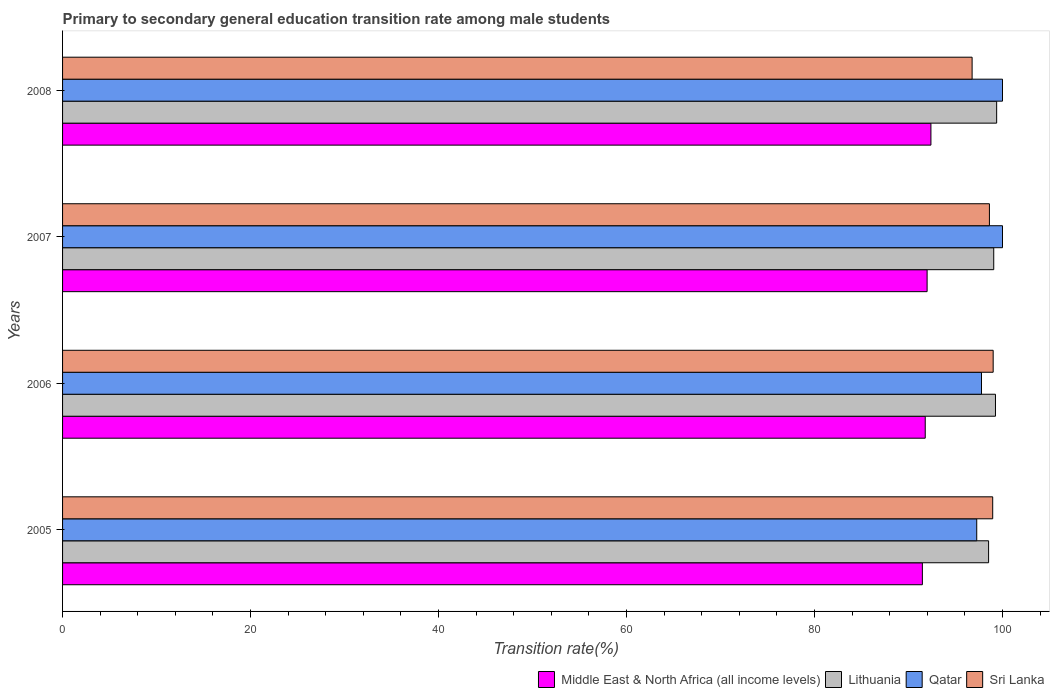How many different coloured bars are there?
Provide a short and direct response. 4. How many groups of bars are there?
Give a very brief answer. 4. Are the number of bars on each tick of the Y-axis equal?
Give a very brief answer. Yes. How many bars are there on the 2nd tick from the top?
Keep it short and to the point. 4. How many bars are there on the 2nd tick from the bottom?
Your answer should be compact. 4. In how many cases, is the number of bars for a given year not equal to the number of legend labels?
Keep it short and to the point. 0. What is the transition rate in Lithuania in 2006?
Your response must be concise. 99.25. Across all years, what is the minimum transition rate in Qatar?
Provide a succinct answer. 97.26. In which year was the transition rate in Middle East & North Africa (all income levels) maximum?
Make the answer very short. 2008. What is the total transition rate in Qatar in the graph?
Ensure brevity in your answer.  395.03. What is the difference between the transition rate in Lithuania in 2005 and that in 2008?
Make the answer very short. -0.86. What is the difference between the transition rate in Middle East & North Africa (all income levels) in 2006 and the transition rate in Qatar in 2008?
Your response must be concise. -8.22. What is the average transition rate in Qatar per year?
Provide a succinct answer. 98.76. In the year 2005, what is the difference between the transition rate in Lithuania and transition rate in Middle East & North Africa (all income levels)?
Make the answer very short. 7.04. What is the ratio of the transition rate in Middle East & North Africa (all income levels) in 2007 to that in 2008?
Keep it short and to the point. 1. What is the difference between the highest and the second highest transition rate in Lithuania?
Offer a terse response. 0.13. What is the difference between the highest and the lowest transition rate in Middle East & North Africa (all income levels)?
Your answer should be very brief. 0.91. Is it the case that in every year, the sum of the transition rate in Sri Lanka and transition rate in Qatar is greater than the sum of transition rate in Middle East & North Africa (all income levels) and transition rate in Lithuania?
Keep it short and to the point. Yes. What does the 1st bar from the top in 2006 represents?
Your response must be concise. Sri Lanka. What does the 4th bar from the bottom in 2007 represents?
Provide a succinct answer. Sri Lanka. Is it the case that in every year, the sum of the transition rate in Sri Lanka and transition rate in Middle East & North Africa (all income levels) is greater than the transition rate in Qatar?
Offer a terse response. Yes. How many bars are there?
Provide a short and direct response. 16. Are the values on the major ticks of X-axis written in scientific E-notation?
Keep it short and to the point. No. Does the graph contain grids?
Provide a succinct answer. No. How many legend labels are there?
Offer a very short reply. 4. What is the title of the graph?
Make the answer very short. Primary to secondary general education transition rate among male students. Does "Uruguay" appear as one of the legend labels in the graph?
Provide a short and direct response. No. What is the label or title of the X-axis?
Give a very brief answer. Transition rate(%). What is the label or title of the Y-axis?
Offer a terse response. Years. What is the Transition rate(%) in Middle East & North Africa (all income levels) in 2005?
Provide a succinct answer. 91.48. What is the Transition rate(%) in Lithuania in 2005?
Offer a terse response. 98.52. What is the Transition rate(%) in Qatar in 2005?
Offer a terse response. 97.26. What is the Transition rate(%) of Sri Lanka in 2005?
Your answer should be compact. 98.96. What is the Transition rate(%) in Middle East & North Africa (all income levels) in 2006?
Keep it short and to the point. 91.78. What is the Transition rate(%) in Lithuania in 2006?
Ensure brevity in your answer.  99.25. What is the Transition rate(%) in Qatar in 2006?
Your answer should be compact. 97.77. What is the Transition rate(%) of Sri Lanka in 2006?
Your answer should be compact. 99.01. What is the Transition rate(%) in Middle East & North Africa (all income levels) in 2007?
Your response must be concise. 91.98. What is the Transition rate(%) in Lithuania in 2007?
Make the answer very short. 99.07. What is the Transition rate(%) of Sri Lanka in 2007?
Make the answer very short. 98.61. What is the Transition rate(%) in Middle East & North Africa (all income levels) in 2008?
Keep it short and to the point. 92.38. What is the Transition rate(%) in Lithuania in 2008?
Keep it short and to the point. 99.38. What is the Transition rate(%) in Sri Lanka in 2008?
Your response must be concise. 96.77. Across all years, what is the maximum Transition rate(%) in Middle East & North Africa (all income levels)?
Your answer should be compact. 92.38. Across all years, what is the maximum Transition rate(%) of Lithuania?
Offer a terse response. 99.38. Across all years, what is the maximum Transition rate(%) of Sri Lanka?
Offer a terse response. 99.01. Across all years, what is the minimum Transition rate(%) in Middle East & North Africa (all income levels)?
Offer a terse response. 91.48. Across all years, what is the minimum Transition rate(%) in Lithuania?
Your response must be concise. 98.52. Across all years, what is the minimum Transition rate(%) in Qatar?
Keep it short and to the point. 97.26. Across all years, what is the minimum Transition rate(%) of Sri Lanka?
Keep it short and to the point. 96.77. What is the total Transition rate(%) of Middle East & North Africa (all income levels) in the graph?
Your response must be concise. 367.62. What is the total Transition rate(%) of Lithuania in the graph?
Your answer should be compact. 396.22. What is the total Transition rate(%) of Qatar in the graph?
Ensure brevity in your answer.  395.02. What is the total Transition rate(%) of Sri Lanka in the graph?
Provide a short and direct response. 393.34. What is the difference between the Transition rate(%) in Middle East & North Africa (all income levels) in 2005 and that in 2006?
Provide a succinct answer. -0.3. What is the difference between the Transition rate(%) of Lithuania in 2005 and that in 2006?
Your answer should be compact. -0.73. What is the difference between the Transition rate(%) in Qatar in 2005 and that in 2006?
Give a very brief answer. -0.51. What is the difference between the Transition rate(%) in Sri Lanka in 2005 and that in 2006?
Keep it short and to the point. -0.05. What is the difference between the Transition rate(%) of Middle East & North Africa (all income levels) in 2005 and that in 2007?
Ensure brevity in your answer.  -0.5. What is the difference between the Transition rate(%) in Lithuania in 2005 and that in 2007?
Ensure brevity in your answer.  -0.55. What is the difference between the Transition rate(%) of Qatar in 2005 and that in 2007?
Provide a succinct answer. -2.74. What is the difference between the Transition rate(%) of Sri Lanka in 2005 and that in 2007?
Provide a short and direct response. 0.35. What is the difference between the Transition rate(%) in Middle East & North Africa (all income levels) in 2005 and that in 2008?
Provide a succinct answer. -0.91. What is the difference between the Transition rate(%) of Lithuania in 2005 and that in 2008?
Offer a very short reply. -0.86. What is the difference between the Transition rate(%) of Qatar in 2005 and that in 2008?
Your answer should be very brief. -2.74. What is the difference between the Transition rate(%) in Sri Lanka in 2005 and that in 2008?
Provide a succinct answer. 2.19. What is the difference between the Transition rate(%) of Middle East & North Africa (all income levels) in 2006 and that in 2007?
Your answer should be compact. -0.2. What is the difference between the Transition rate(%) of Lithuania in 2006 and that in 2007?
Provide a succinct answer. 0.18. What is the difference between the Transition rate(%) in Qatar in 2006 and that in 2007?
Offer a terse response. -2.23. What is the difference between the Transition rate(%) of Sri Lanka in 2006 and that in 2007?
Keep it short and to the point. 0.4. What is the difference between the Transition rate(%) in Middle East & North Africa (all income levels) in 2006 and that in 2008?
Your answer should be compact. -0.6. What is the difference between the Transition rate(%) of Lithuania in 2006 and that in 2008?
Offer a terse response. -0.13. What is the difference between the Transition rate(%) in Qatar in 2006 and that in 2008?
Keep it short and to the point. -2.23. What is the difference between the Transition rate(%) in Sri Lanka in 2006 and that in 2008?
Provide a short and direct response. 2.24. What is the difference between the Transition rate(%) in Middle East & North Africa (all income levels) in 2007 and that in 2008?
Your answer should be very brief. -0.4. What is the difference between the Transition rate(%) in Lithuania in 2007 and that in 2008?
Provide a short and direct response. -0.31. What is the difference between the Transition rate(%) of Qatar in 2007 and that in 2008?
Provide a short and direct response. 0. What is the difference between the Transition rate(%) of Sri Lanka in 2007 and that in 2008?
Make the answer very short. 1.84. What is the difference between the Transition rate(%) in Middle East & North Africa (all income levels) in 2005 and the Transition rate(%) in Lithuania in 2006?
Your answer should be very brief. -7.78. What is the difference between the Transition rate(%) in Middle East & North Africa (all income levels) in 2005 and the Transition rate(%) in Qatar in 2006?
Your response must be concise. -6.29. What is the difference between the Transition rate(%) of Middle East & North Africa (all income levels) in 2005 and the Transition rate(%) of Sri Lanka in 2006?
Your answer should be compact. -7.53. What is the difference between the Transition rate(%) in Lithuania in 2005 and the Transition rate(%) in Qatar in 2006?
Make the answer very short. 0.75. What is the difference between the Transition rate(%) in Lithuania in 2005 and the Transition rate(%) in Sri Lanka in 2006?
Provide a short and direct response. -0.49. What is the difference between the Transition rate(%) in Qatar in 2005 and the Transition rate(%) in Sri Lanka in 2006?
Offer a terse response. -1.75. What is the difference between the Transition rate(%) in Middle East & North Africa (all income levels) in 2005 and the Transition rate(%) in Lithuania in 2007?
Keep it short and to the point. -7.59. What is the difference between the Transition rate(%) in Middle East & North Africa (all income levels) in 2005 and the Transition rate(%) in Qatar in 2007?
Give a very brief answer. -8.52. What is the difference between the Transition rate(%) in Middle East & North Africa (all income levels) in 2005 and the Transition rate(%) in Sri Lanka in 2007?
Make the answer very short. -7.13. What is the difference between the Transition rate(%) in Lithuania in 2005 and the Transition rate(%) in Qatar in 2007?
Provide a short and direct response. -1.48. What is the difference between the Transition rate(%) in Lithuania in 2005 and the Transition rate(%) in Sri Lanka in 2007?
Provide a short and direct response. -0.09. What is the difference between the Transition rate(%) of Qatar in 2005 and the Transition rate(%) of Sri Lanka in 2007?
Keep it short and to the point. -1.35. What is the difference between the Transition rate(%) in Middle East & North Africa (all income levels) in 2005 and the Transition rate(%) in Lithuania in 2008?
Provide a short and direct response. -7.9. What is the difference between the Transition rate(%) of Middle East & North Africa (all income levels) in 2005 and the Transition rate(%) of Qatar in 2008?
Your response must be concise. -8.52. What is the difference between the Transition rate(%) in Middle East & North Africa (all income levels) in 2005 and the Transition rate(%) in Sri Lanka in 2008?
Offer a very short reply. -5.29. What is the difference between the Transition rate(%) of Lithuania in 2005 and the Transition rate(%) of Qatar in 2008?
Ensure brevity in your answer.  -1.48. What is the difference between the Transition rate(%) of Lithuania in 2005 and the Transition rate(%) of Sri Lanka in 2008?
Provide a succinct answer. 1.75. What is the difference between the Transition rate(%) in Qatar in 2005 and the Transition rate(%) in Sri Lanka in 2008?
Your answer should be compact. 0.49. What is the difference between the Transition rate(%) in Middle East & North Africa (all income levels) in 2006 and the Transition rate(%) in Lithuania in 2007?
Provide a short and direct response. -7.29. What is the difference between the Transition rate(%) in Middle East & North Africa (all income levels) in 2006 and the Transition rate(%) in Qatar in 2007?
Give a very brief answer. -8.22. What is the difference between the Transition rate(%) in Middle East & North Africa (all income levels) in 2006 and the Transition rate(%) in Sri Lanka in 2007?
Keep it short and to the point. -6.83. What is the difference between the Transition rate(%) in Lithuania in 2006 and the Transition rate(%) in Qatar in 2007?
Ensure brevity in your answer.  -0.75. What is the difference between the Transition rate(%) in Lithuania in 2006 and the Transition rate(%) in Sri Lanka in 2007?
Ensure brevity in your answer.  0.64. What is the difference between the Transition rate(%) of Qatar in 2006 and the Transition rate(%) of Sri Lanka in 2007?
Your response must be concise. -0.84. What is the difference between the Transition rate(%) of Middle East & North Africa (all income levels) in 2006 and the Transition rate(%) of Lithuania in 2008?
Make the answer very short. -7.6. What is the difference between the Transition rate(%) in Middle East & North Africa (all income levels) in 2006 and the Transition rate(%) in Qatar in 2008?
Offer a terse response. -8.22. What is the difference between the Transition rate(%) in Middle East & North Africa (all income levels) in 2006 and the Transition rate(%) in Sri Lanka in 2008?
Provide a succinct answer. -4.99. What is the difference between the Transition rate(%) in Lithuania in 2006 and the Transition rate(%) in Qatar in 2008?
Provide a succinct answer. -0.75. What is the difference between the Transition rate(%) of Lithuania in 2006 and the Transition rate(%) of Sri Lanka in 2008?
Your answer should be compact. 2.48. What is the difference between the Transition rate(%) of Middle East & North Africa (all income levels) in 2007 and the Transition rate(%) of Lithuania in 2008?
Ensure brevity in your answer.  -7.4. What is the difference between the Transition rate(%) of Middle East & North Africa (all income levels) in 2007 and the Transition rate(%) of Qatar in 2008?
Your answer should be compact. -8.02. What is the difference between the Transition rate(%) of Middle East & North Africa (all income levels) in 2007 and the Transition rate(%) of Sri Lanka in 2008?
Keep it short and to the point. -4.79. What is the difference between the Transition rate(%) in Lithuania in 2007 and the Transition rate(%) in Qatar in 2008?
Your answer should be very brief. -0.93. What is the difference between the Transition rate(%) of Lithuania in 2007 and the Transition rate(%) of Sri Lanka in 2008?
Offer a very short reply. 2.3. What is the difference between the Transition rate(%) in Qatar in 2007 and the Transition rate(%) in Sri Lanka in 2008?
Ensure brevity in your answer.  3.23. What is the average Transition rate(%) of Middle East & North Africa (all income levels) per year?
Keep it short and to the point. 91.9. What is the average Transition rate(%) of Lithuania per year?
Your answer should be very brief. 99.05. What is the average Transition rate(%) of Qatar per year?
Provide a short and direct response. 98.76. What is the average Transition rate(%) of Sri Lanka per year?
Offer a terse response. 98.34. In the year 2005, what is the difference between the Transition rate(%) in Middle East & North Africa (all income levels) and Transition rate(%) in Lithuania?
Offer a terse response. -7.04. In the year 2005, what is the difference between the Transition rate(%) of Middle East & North Africa (all income levels) and Transition rate(%) of Qatar?
Provide a succinct answer. -5.78. In the year 2005, what is the difference between the Transition rate(%) in Middle East & North Africa (all income levels) and Transition rate(%) in Sri Lanka?
Provide a short and direct response. -7.48. In the year 2005, what is the difference between the Transition rate(%) in Lithuania and Transition rate(%) in Qatar?
Provide a succinct answer. 1.26. In the year 2005, what is the difference between the Transition rate(%) of Lithuania and Transition rate(%) of Sri Lanka?
Your response must be concise. -0.44. In the year 2005, what is the difference between the Transition rate(%) in Qatar and Transition rate(%) in Sri Lanka?
Make the answer very short. -1.7. In the year 2006, what is the difference between the Transition rate(%) in Middle East & North Africa (all income levels) and Transition rate(%) in Lithuania?
Give a very brief answer. -7.47. In the year 2006, what is the difference between the Transition rate(%) of Middle East & North Africa (all income levels) and Transition rate(%) of Qatar?
Keep it short and to the point. -5.99. In the year 2006, what is the difference between the Transition rate(%) of Middle East & North Africa (all income levels) and Transition rate(%) of Sri Lanka?
Give a very brief answer. -7.23. In the year 2006, what is the difference between the Transition rate(%) in Lithuania and Transition rate(%) in Qatar?
Provide a short and direct response. 1.49. In the year 2006, what is the difference between the Transition rate(%) of Lithuania and Transition rate(%) of Sri Lanka?
Your response must be concise. 0.24. In the year 2006, what is the difference between the Transition rate(%) of Qatar and Transition rate(%) of Sri Lanka?
Offer a terse response. -1.24. In the year 2007, what is the difference between the Transition rate(%) of Middle East & North Africa (all income levels) and Transition rate(%) of Lithuania?
Make the answer very short. -7.09. In the year 2007, what is the difference between the Transition rate(%) in Middle East & North Africa (all income levels) and Transition rate(%) in Qatar?
Make the answer very short. -8.02. In the year 2007, what is the difference between the Transition rate(%) in Middle East & North Africa (all income levels) and Transition rate(%) in Sri Lanka?
Offer a terse response. -6.63. In the year 2007, what is the difference between the Transition rate(%) in Lithuania and Transition rate(%) in Qatar?
Ensure brevity in your answer.  -0.93. In the year 2007, what is the difference between the Transition rate(%) in Lithuania and Transition rate(%) in Sri Lanka?
Keep it short and to the point. 0.46. In the year 2007, what is the difference between the Transition rate(%) of Qatar and Transition rate(%) of Sri Lanka?
Your answer should be very brief. 1.39. In the year 2008, what is the difference between the Transition rate(%) in Middle East & North Africa (all income levels) and Transition rate(%) in Lithuania?
Provide a succinct answer. -6.99. In the year 2008, what is the difference between the Transition rate(%) of Middle East & North Africa (all income levels) and Transition rate(%) of Qatar?
Keep it short and to the point. -7.62. In the year 2008, what is the difference between the Transition rate(%) of Middle East & North Africa (all income levels) and Transition rate(%) of Sri Lanka?
Provide a short and direct response. -4.38. In the year 2008, what is the difference between the Transition rate(%) of Lithuania and Transition rate(%) of Qatar?
Your answer should be compact. -0.62. In the year 2008, what is the difference between the Transition rate(%) of Lithuania and Transition rate(%) of Sri Lanka?
Your response must be concise. 2.61. In the year 2008, what is the difference between the Transition rate(%) of Qatar and Transition rate(%) of Sri Lanka?
Provide a succinct answer. 3.23. What is the ratio of the Transition rate(%) of Qatar in 2005 to that in 2006?
Offer a very short reply. 0.99. What is the ratio of the Transition rate(%) of Lithuania in 2005 to that in 2007?
Your answer should be compact. 0.99. What is the ratio of the Transition rate(%) of Qatar in 2005 to that in 2007?
Your answer should be very brief. 0.97. What is the ratio of the Transition rate(%) of Sri Lanka in 2005 to that in 2007?
Give a very brief answer. 1. What is the ratio of the Transition rate(%) of Middle East & North Africa (all income levels) in 2005 to that in 2008?
Your response must be concise. 0.99. What is the ratio of the Transition rate(%) of Qatar in 2005 to that in 2008?
Provide a succinct answer. 0.97. What is the ratio of the Transition rate(%) in Sri Lanka in 2005 to that in 2008?
Offer a terse response. 1.02. What is the ratio of the Transition rate(%) of Middle East & North Africa (all income levels) in 2006 to that in 2007?
Keep it short and to the point. 1. What is the ratio of the Transition rate(%) of Qatar in 2006 to that in 2007?
Make the answer very short. 0.98. What is the ratio of the Transition rate(%) of Middle East & North Africa (all income levels) in 2006 to that in 2008?
Your answer should be very brief. 0.99. What is the ratio of the Transition rate(%) in Lithuania in 2006 to that in 2008?
Keep it short and to the point. 1. What is the ratio of the Transition rate(%) in Qatar in 2006 to that in 2008?
Your answer should be very brief. 0.98. What is the ratio of the Transition rate(%) in Sri Lanka in 2006 to that in 2008?
Your response must be concise. 1.02. What is the ratio of the Transition rate(%) in Middle East & North Africa (all income levels) in 2007 to that in 2008?
Provide a succinct answer. 1. What is the ratio of the Transition rate(%) in Lithuania in 2007 to that in 2008?
Offer a terse response. 1. What is the ratio of the Transition rate(%) of Qatar in 2007 to that in 2008?
Your answer should be very brief. 1. What is the difference between the highest and the second highest Transition rate(%) in Middle East & North Africa (all income levels)?
Make the answer very short. 0.4. What is the difference between the highest and the second highest Transition rate(%) in Lithuania?
Make the answer very short. 0.13. What is the difference between the highest and the second highest Transition rate(%) of Qatar?
Give a very brief answer. 0. What is the difference between the highest and the second highest Transition rate(%) in Sri Lanka?
Ensure brevity in your answer.  0.05. What is the difference between the highest and the lowest Transition rate(%) of Middle East & North Africa (all income levels)?
Ensure brevity in your answer.  0.91. What is the difference between the highest and the lowest Transition rate(%) in Lithuania?
Provide a short and direct response. 0.86. What is the difference between the highest and the lowest Transition rate(%) in Qatar?
Offer a terse response. 2.74. What is the difference between the highest and the lowest Transition rate(%) in Sri Lanka?
Your answer should be very brief. 2.24. 